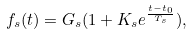<formula> <loc_0><loc_0><loc_500><loc_500>f _ { s } ( t ) = G _ { s } ( 1 + K _ { s } e ^ { \frac { t - t _ { 0 } } { T _ { s } } } ) ,</formula> 